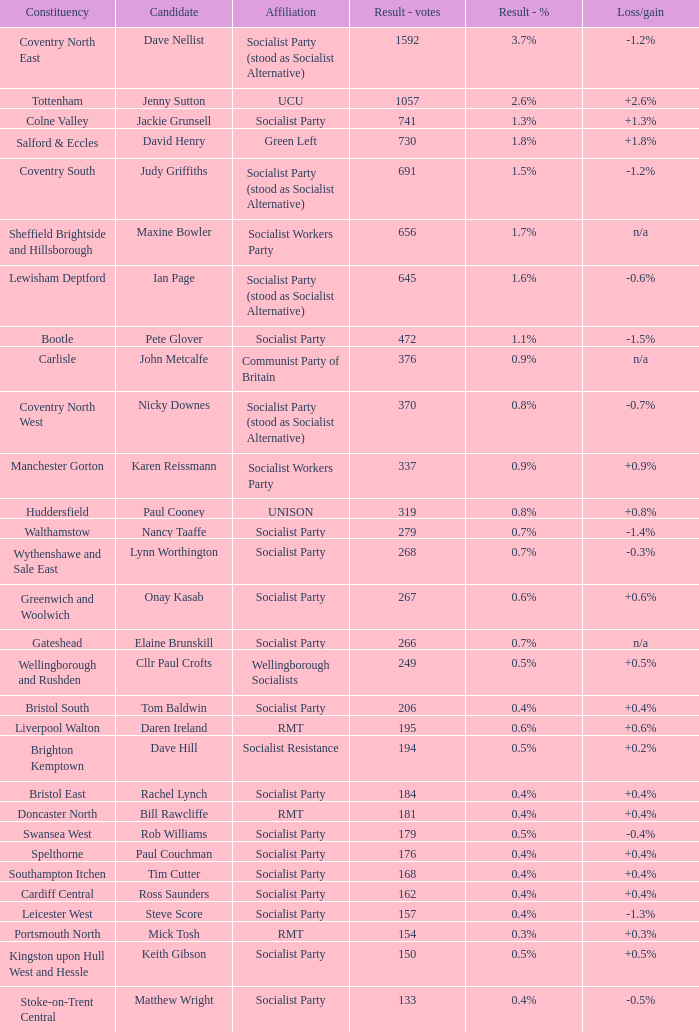What are all the ties for candidate daren ireland? RMT. 